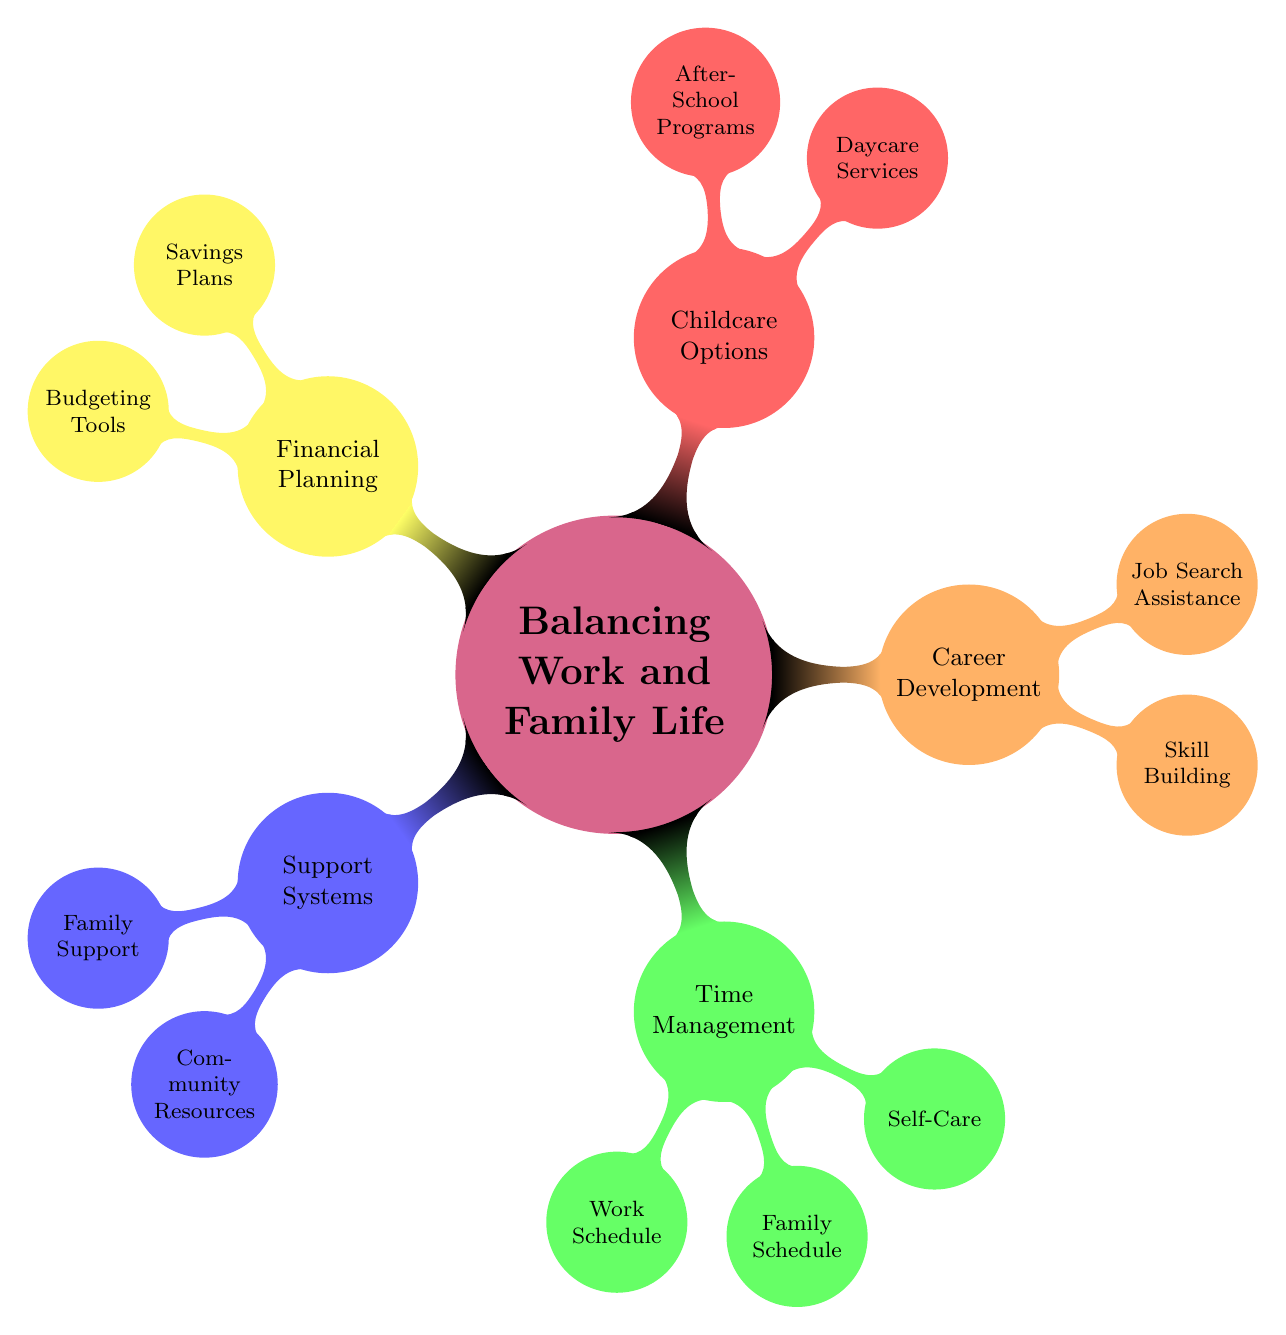What are the two categories under Support Systems? The diagram lists "Family Support" and "Community Resources" as the two categories under the main node "Support Systems".
Answer: Family Support, Community Resources How many nodes are there under Time Management? The Time Management category contains three nodes: "Work Schedule", "Family Schedule", and "Self-Care", making a total of three nodes.
Answer: 3 What is one type of Childcare Option mentioned? The diagram provides "Daycare Services" and "After-School Programs" under the Childcare Options category; thus, one type is "Daycare Services".
Answer: Daycare Services Which node under Career Development focuses on improving qualifications? The node "Skill Building" pertains to improving qualifications through online courses, workshops, and certifications.
Answer: Skill Building How many examples of Family Support are listed? The Family Support category contains three examples: "Grandparents", "Siblings", and "Close Friends", totaling three.
Answer: 3 What is the relationship between Financial Planning and Budgeting Tools? "Budgeting Tools" is a subcategory under "Financial Planning", indicating that budgeting tools are methods or resources within the broader concept of financial planning.
Answer: Budgeting Tools Which category has the most nodes? The Time Management category has the most nodes with three different focus areas: "Work Schedule", "Family Schedule", and "Self-Care", while others have fewer.
Answer: Time Management What are two community resources listed under Support Systems? Two examples listed are "Parenting Groups" and "Local Nonprofits", which belong under the Community Resources node.
Answer: Parenting Groups, Local Nonprofits 